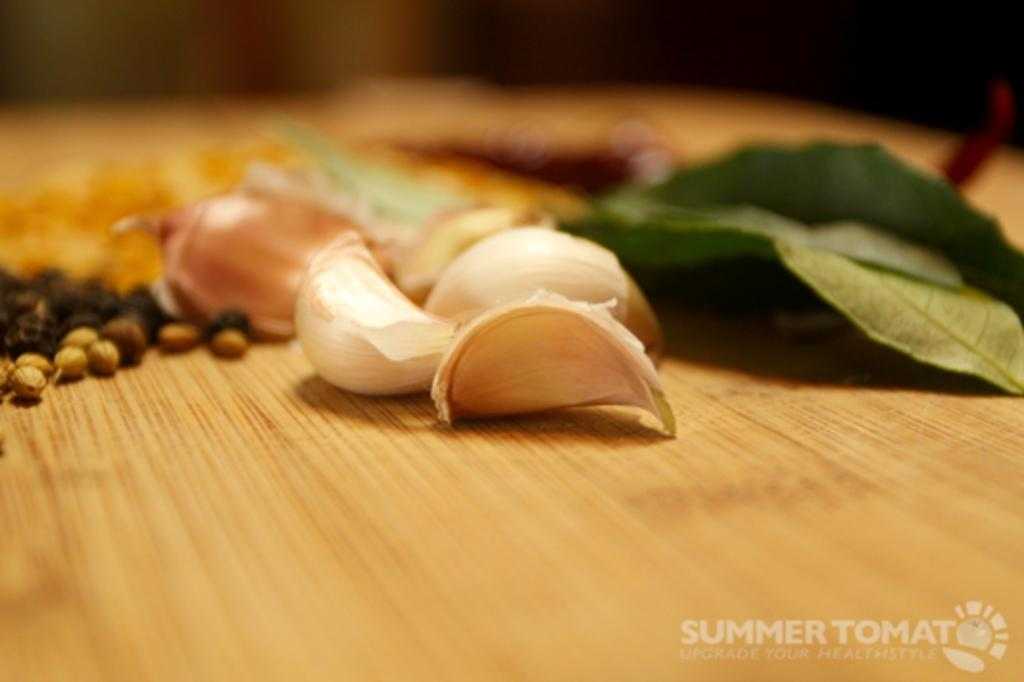What type of food item is present in the image? There is garlic in the image. What type of plant material is present in the image? There is a leaf in the image. What is the surface on which objects are placed in the image? There are objects on a platform in the image. Where can text be found in the image? There is text in the bottom right corner of the image. What type of kettle is visible in the image? There is no kettle present in the image. How does the garlic talk to the leaf in the image? Neither the garlic nor the leaf can talk, as they are inanimate objects. 